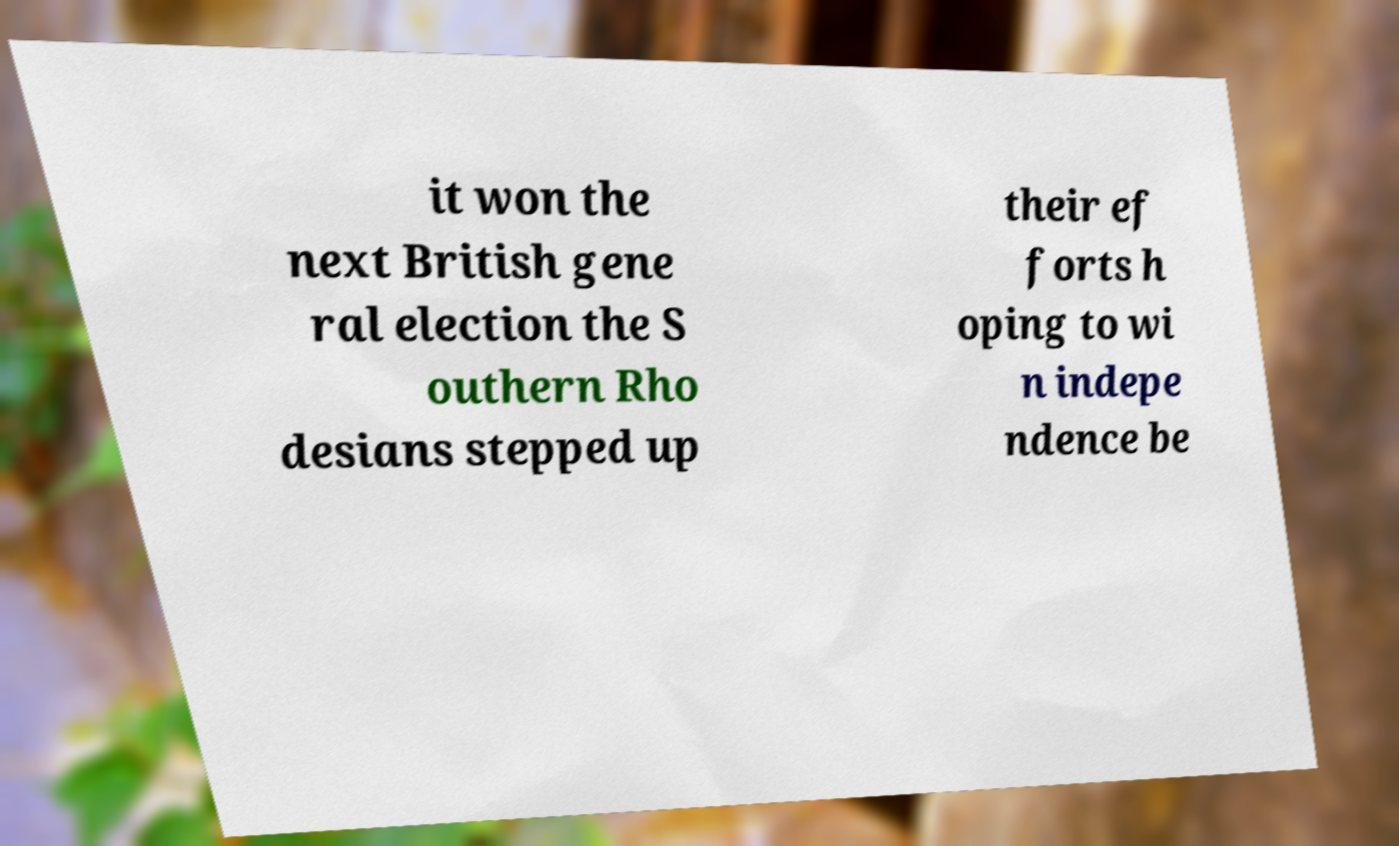Can you read and provide the text displayed in the image?This photo seems to have some interesting text. Can you extract and type it out for me? it won the next British gene ral election the S outhern Rho desians stepped up their ef forts h oping to wi n indepe ndence be 